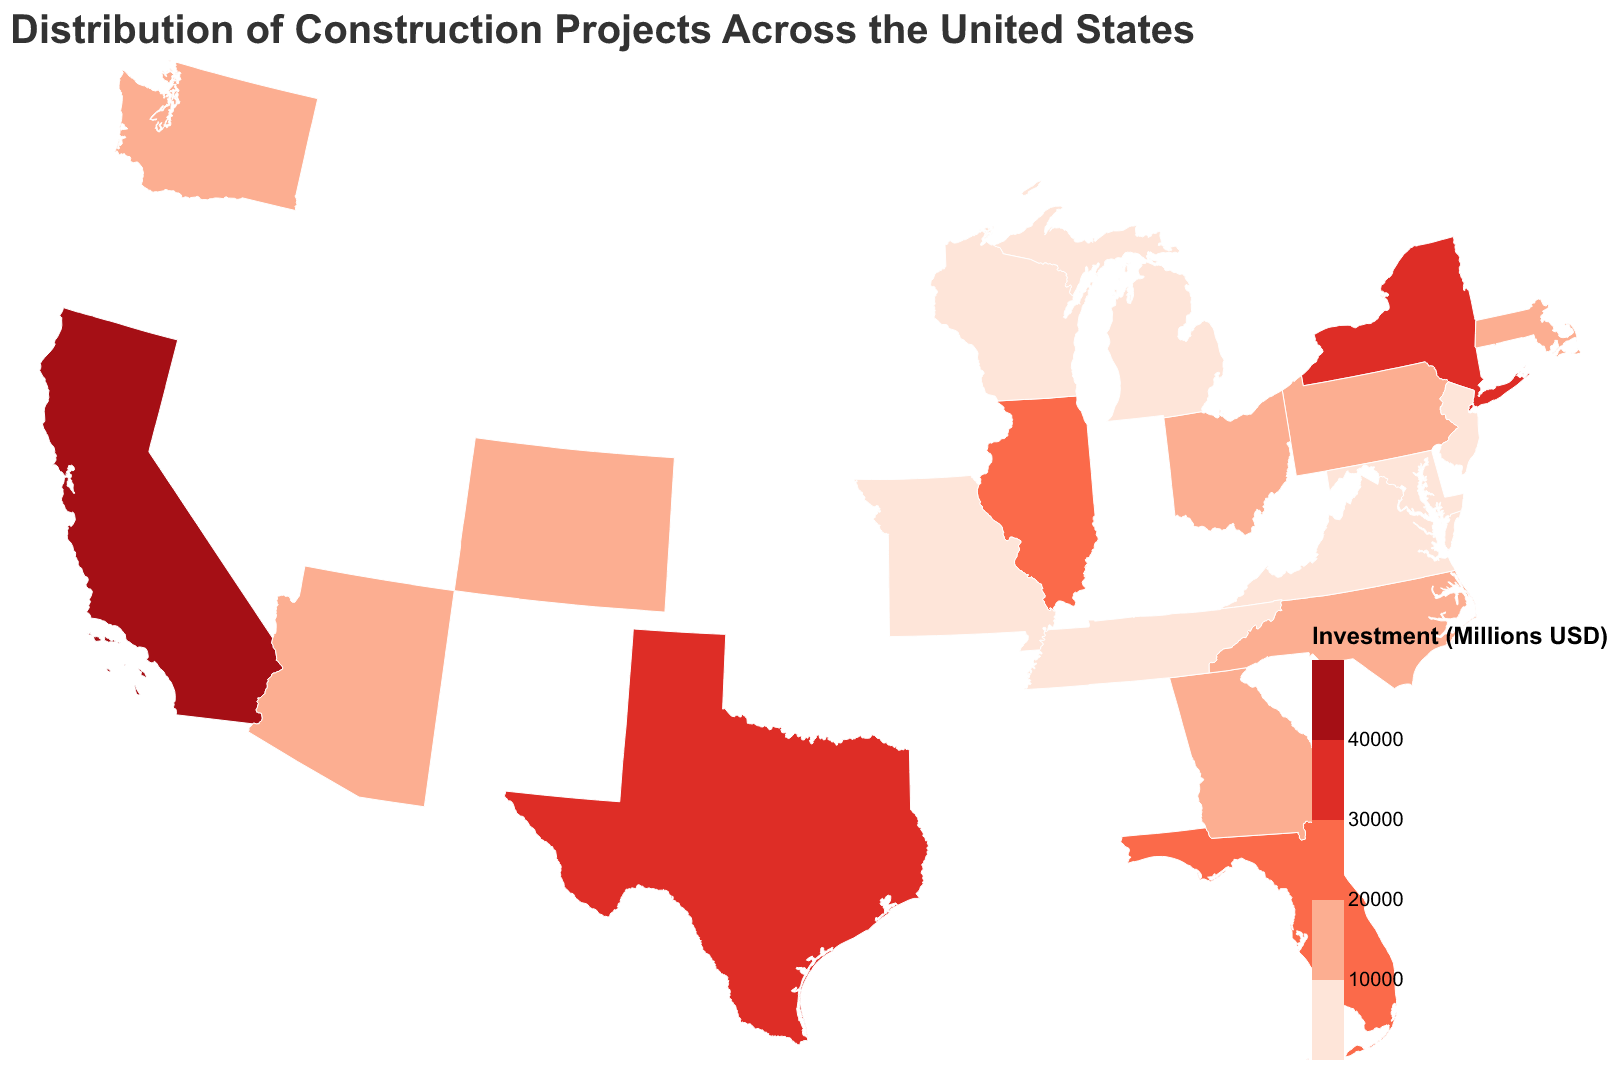What's the title of the figure? The title can be found at the top of the figure. It reads "Distribution of Construction Projects Across the United States".
Answer: Distribution of Construction Projects Across the United States Which state has the highest investment in construction projects? The state with the darkest color on the map and the highest investment value in the tooltip indicates the state with the highest investment. California has the highest at 45,000 million USD.
Answer: California What's the total investment in the Southeast region? Sum the investments of states in the Southeast region (Florida, Georgia, North Carolina, Virginia, Tennessee): 29,000 + 15,000 + 13,000 + 9,500 + 8,000 = 74,500 million USD.
Answer: 74,500 million USD What color represents states with less than 10,000 million USD investment? By referring to the color legend, states with investments less than 10,000 million USD are represented by the lightest color.
Answer: #fee5d9 (light pink) Which regions have states with investments greater than 30,000 million USD? Identify regions that have states with darker colors representing investments over 30,000 million USD. The states are California in the West and Texas in the South.
Answer: West, South Which states in the Midwest have investments below 10,000 million USD? By examining the states in the Midwest region and their corresponding investment values, the states with less than 10,000 million USD are Michigan, Missouri, and Wisconsin.
Answer: Michigan, Missouri, Wisconsin Rank the top three states by investment. Based on the investment values from highest to lowest: 
1. California (45,000 million USD)
2. Texas (38,000 million USD)
3. New York (32,000 million USD).
Answer: 1. California 2. Texas 3. New York Which state has the lowest investment, and in which region is it located? The state with the lightest color and the lowest value in the tooltip indicates the lowest investment. Wisconsin has the lowest at 6,500 million USD and is in the Midwest.
Answer: Wisconsin, Midwest 